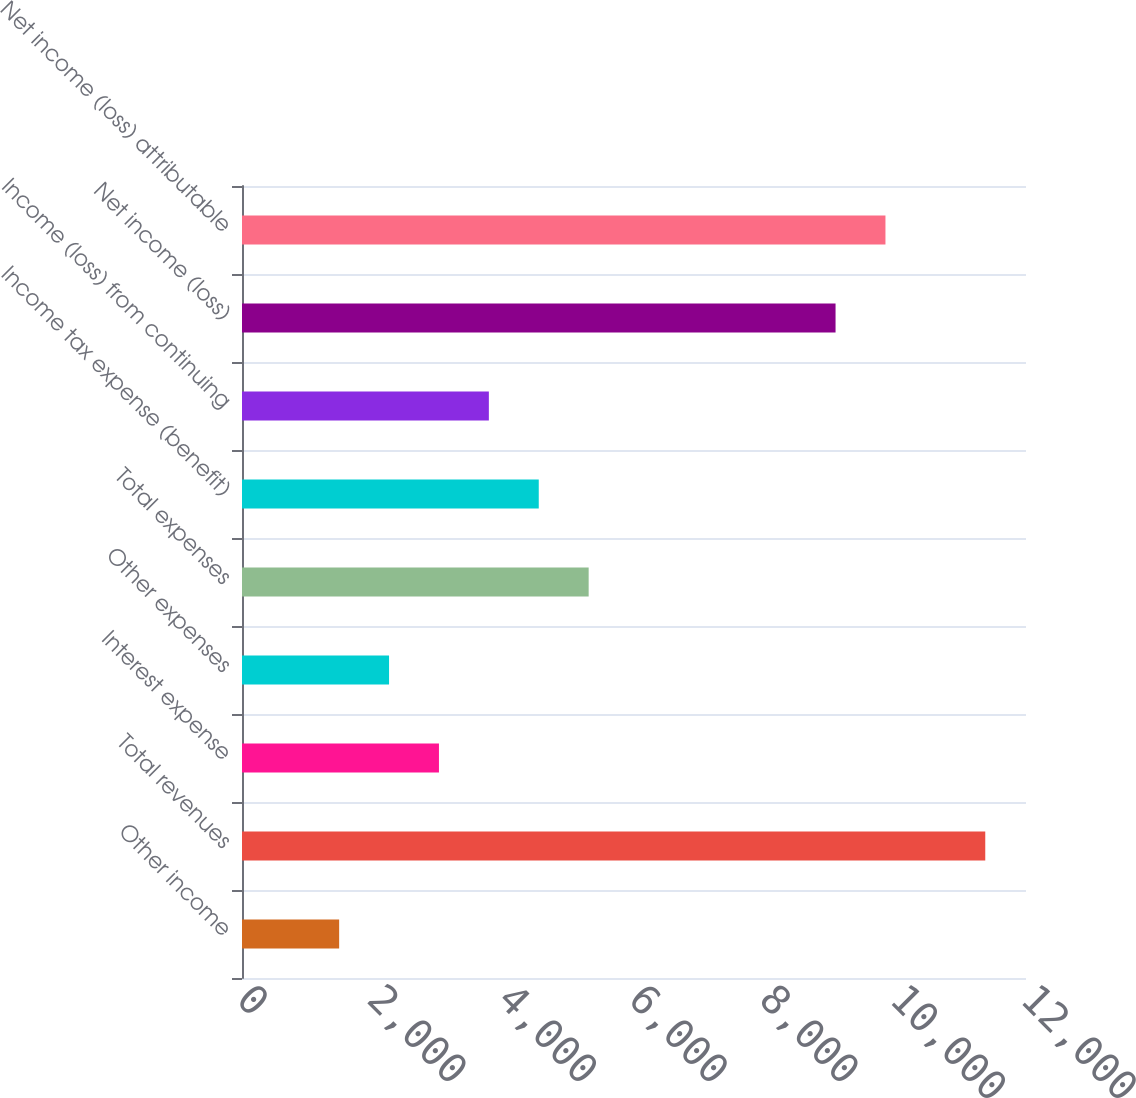Convert chart. <chart><loc_0><loc_0><loc_500><loc_500><bar_chart><fcel>Other income<fcel>Total revenues<fcel>Interest expense<fcel>Other expenses<fcel>Total expenses<fcel>Income tax expense (benefit)<fcel>Income (loss) from continuing<fcel>Net income (loss)<fcel>Net income (loss) attributable<nl><fcel>1487<fcel>11376.4<fcel>3014.6<fcel>2250.8<fcel>5306<fcel>4542.2<fcel>3778.4<fcel>9085<fcel>9848.8<nl></chart> 